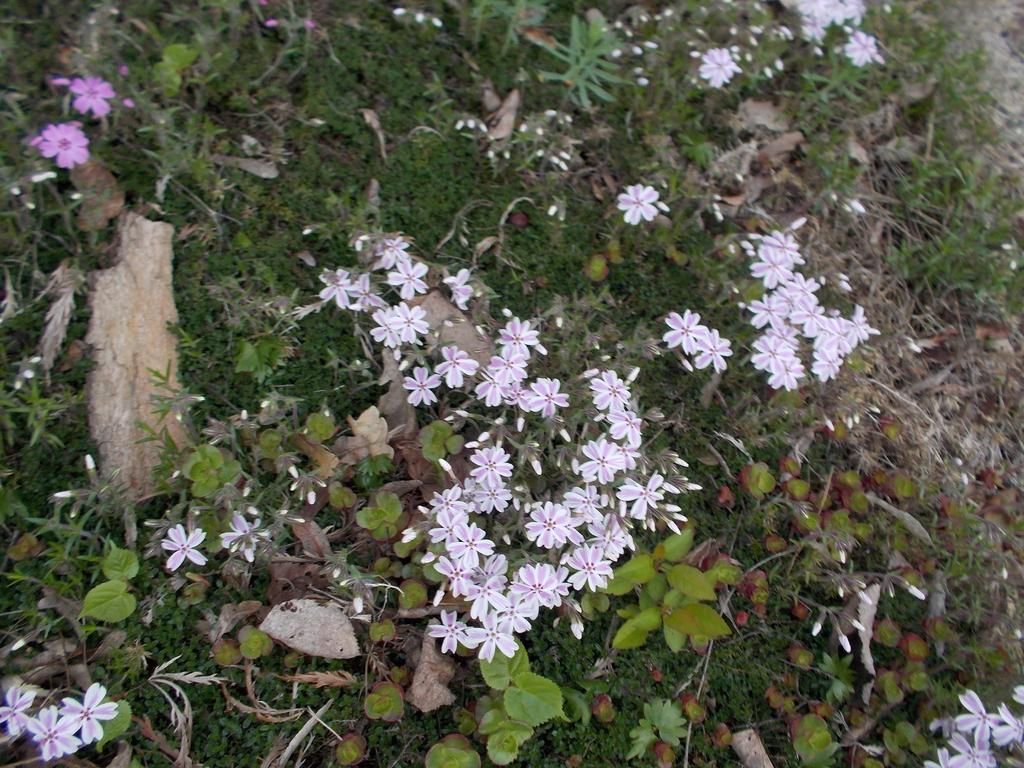What type of plants can be seen in the image? There are plants with flowers in the image. What can be found on the plants besides flowers? There are leaves on the plants. What is located on the left side of the image? There appears to be a rock on the left side of the image. Where is the print of the lunchroom located in the image? There is no print of a lunchroom present in the image. What type of mint can be seen growing among the plants in the image? There is no mint present in the image; it only features plants with flowers and leaves. 